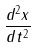<formula> <loc_0><loc_0><loc_500><loc_500>\frac { d ^ { 2 } x } { d t ^ { 2 } }</formula> 